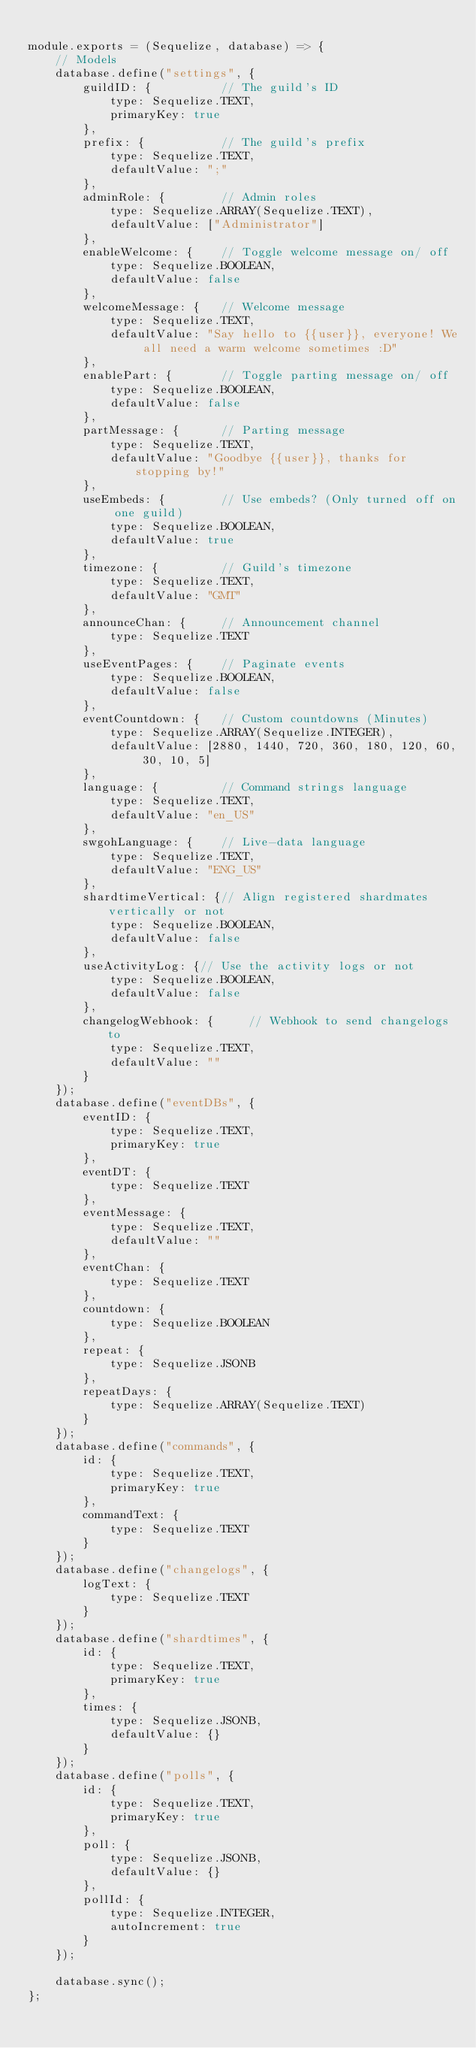Convert code to text. <code><loc_0><loc_0><loc_500><loc_500><_JavaScript_>
module.exports = (Sequelize, database) => {
    // Models
    database.define("settings", {
        guildID: {          // The guild's ID
            type: Sequelize.TEXT,
            primaryKey: true
        },
        prefix: {           // The guild's prefix
            type: Sequelize.TEXT,
            defaultValue: ";"
        },
        adminRole: {        // Admin roles
            type: Sequelize.ARRAY(Sequelize.TEXT),
            defaultValue: ["Administrator"]
        },
        enableWelcome: {    // Toggle welcome message on/ off
            type: Sequelize.BOOLEAN,
            defaultValue: false
        },
        welcomeMessage: {   // Welcome message
            type: Sequelize.TEXT,
            defaultValue: "Say hello to {{user}}, everyone! We all need a warm welcome sometimes :D"
        },
        enablePart: {       // Toggle parting message on/ off
            type: Sequelize.BOOLEAN,
            defaultValue: false
        },
        partMessage: {      // Parting message
            type: Sequelize.TEXT,
            defaultValue: "Goodbye {{user}}, thanks for stopping by!"
        },
        useEmbeds: {        // Use embeds? (Only turned off on one guild)
            type: Sequelize.BOOLEAN,
            defaultValue: true
        },
        timezone: {         // Guild's timezone
            type: Sequelize.TEXT,
            defaultValue: "GMT"
        },
        announceChan: {     // Announcement channel
            type: Sequelize.TEXT
        },
        useEventPages: {    // Paginate events
            type: Sequelize.BOOLEAN,
            defaultValue: false
        },
        eventCountdown: {   // Custom countdowns (Minutes)
            type: Sequelize.ARRAY(Sequelize.INTEGER),
            defaultValue: [2880, 1440, 720, 360, 180, 120, 60, 30, 10, 5]
        },
        language: {         // Command strings language
            type: Sequelize.TEXT,
            defaultValue: "en_US"
        },
        swgohLanguage: {    // Live-data language
            type: Sequelize.TEXT,
            defaultValue: "ENG_US"
        },
        shardtimeVertical: {// Align registered shardmates vertically or not
            type: Sequelize.BOOLEAN,
            defaultValue: false
        },
        useActivityLog: {// Use the activity logs or not
            type: Sequelize.BOOLEAN,
            defaultValue: false
        },
        changelogWebhook: {     // Webhook to send changelogs to
            type: Sequelize.TEXT,
            defaultValue: ""
        }
    });
    database.define("eventDBs", {
        eventID: {
            type: Sequelize.TEXT,
            primaryKey: true
        },
        eventDT: {
            type: Sequelize.TEXT
        },
        eventMessage: {
            type: Sequelize.TEXT,
            defaultValue: ""
        },
        eventChan: {
            type: Sequelize.TEXT
        },
        countdown: {
            type: Sequelize.BOOLEAN
        },
        repeat: {
            type: Sequelize.JSONB
        },
        repeatDays: {
            type: Sequelize.ARRAY(Sequelize.TEXT)
        }
    });
    database.define("commands", {
        id: {
            type: Sequelize.TEXT,
            primaryKey: true
        },
        commandText: {
            type: Sequelize.TEXT
        }
    });
    database.define("changelogs", {
        logText: {
            type: Sequelize.TEXT
        }
    });
    database.define("shardtimes", {
        id: {
            type: Sequelize.TEXT,
            primaryKey: true
        },
        times: {
            type: Sequelize.JSONB,
            defaultValue: {}
        }
    });
    database.define("polls", {
        id: {
            type: Sequelize.TEXT,
            primaryKey: true
        },
        poll: {
            type: Sequelize.JSONB,
            defaultValue: {}
        },
        pollId: {
            type: Sequelize.INTEGER,
            autoIncrement: true
        }
    });

    database.sync();
};
</code> 